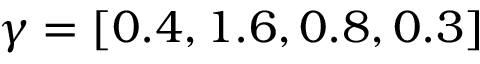Convert formula to latex. <formula><loc_0><loc_0><loc_500><loc_500>\gamma = [ 0 . 4 , 1 . 6 , 0 . 8 , 0 . 3 ]</formula> 